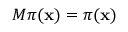<formula> <loc_0><loc_0><loc_500><loc_500>M \pi ( x ) = \pi ( x )</formula> 